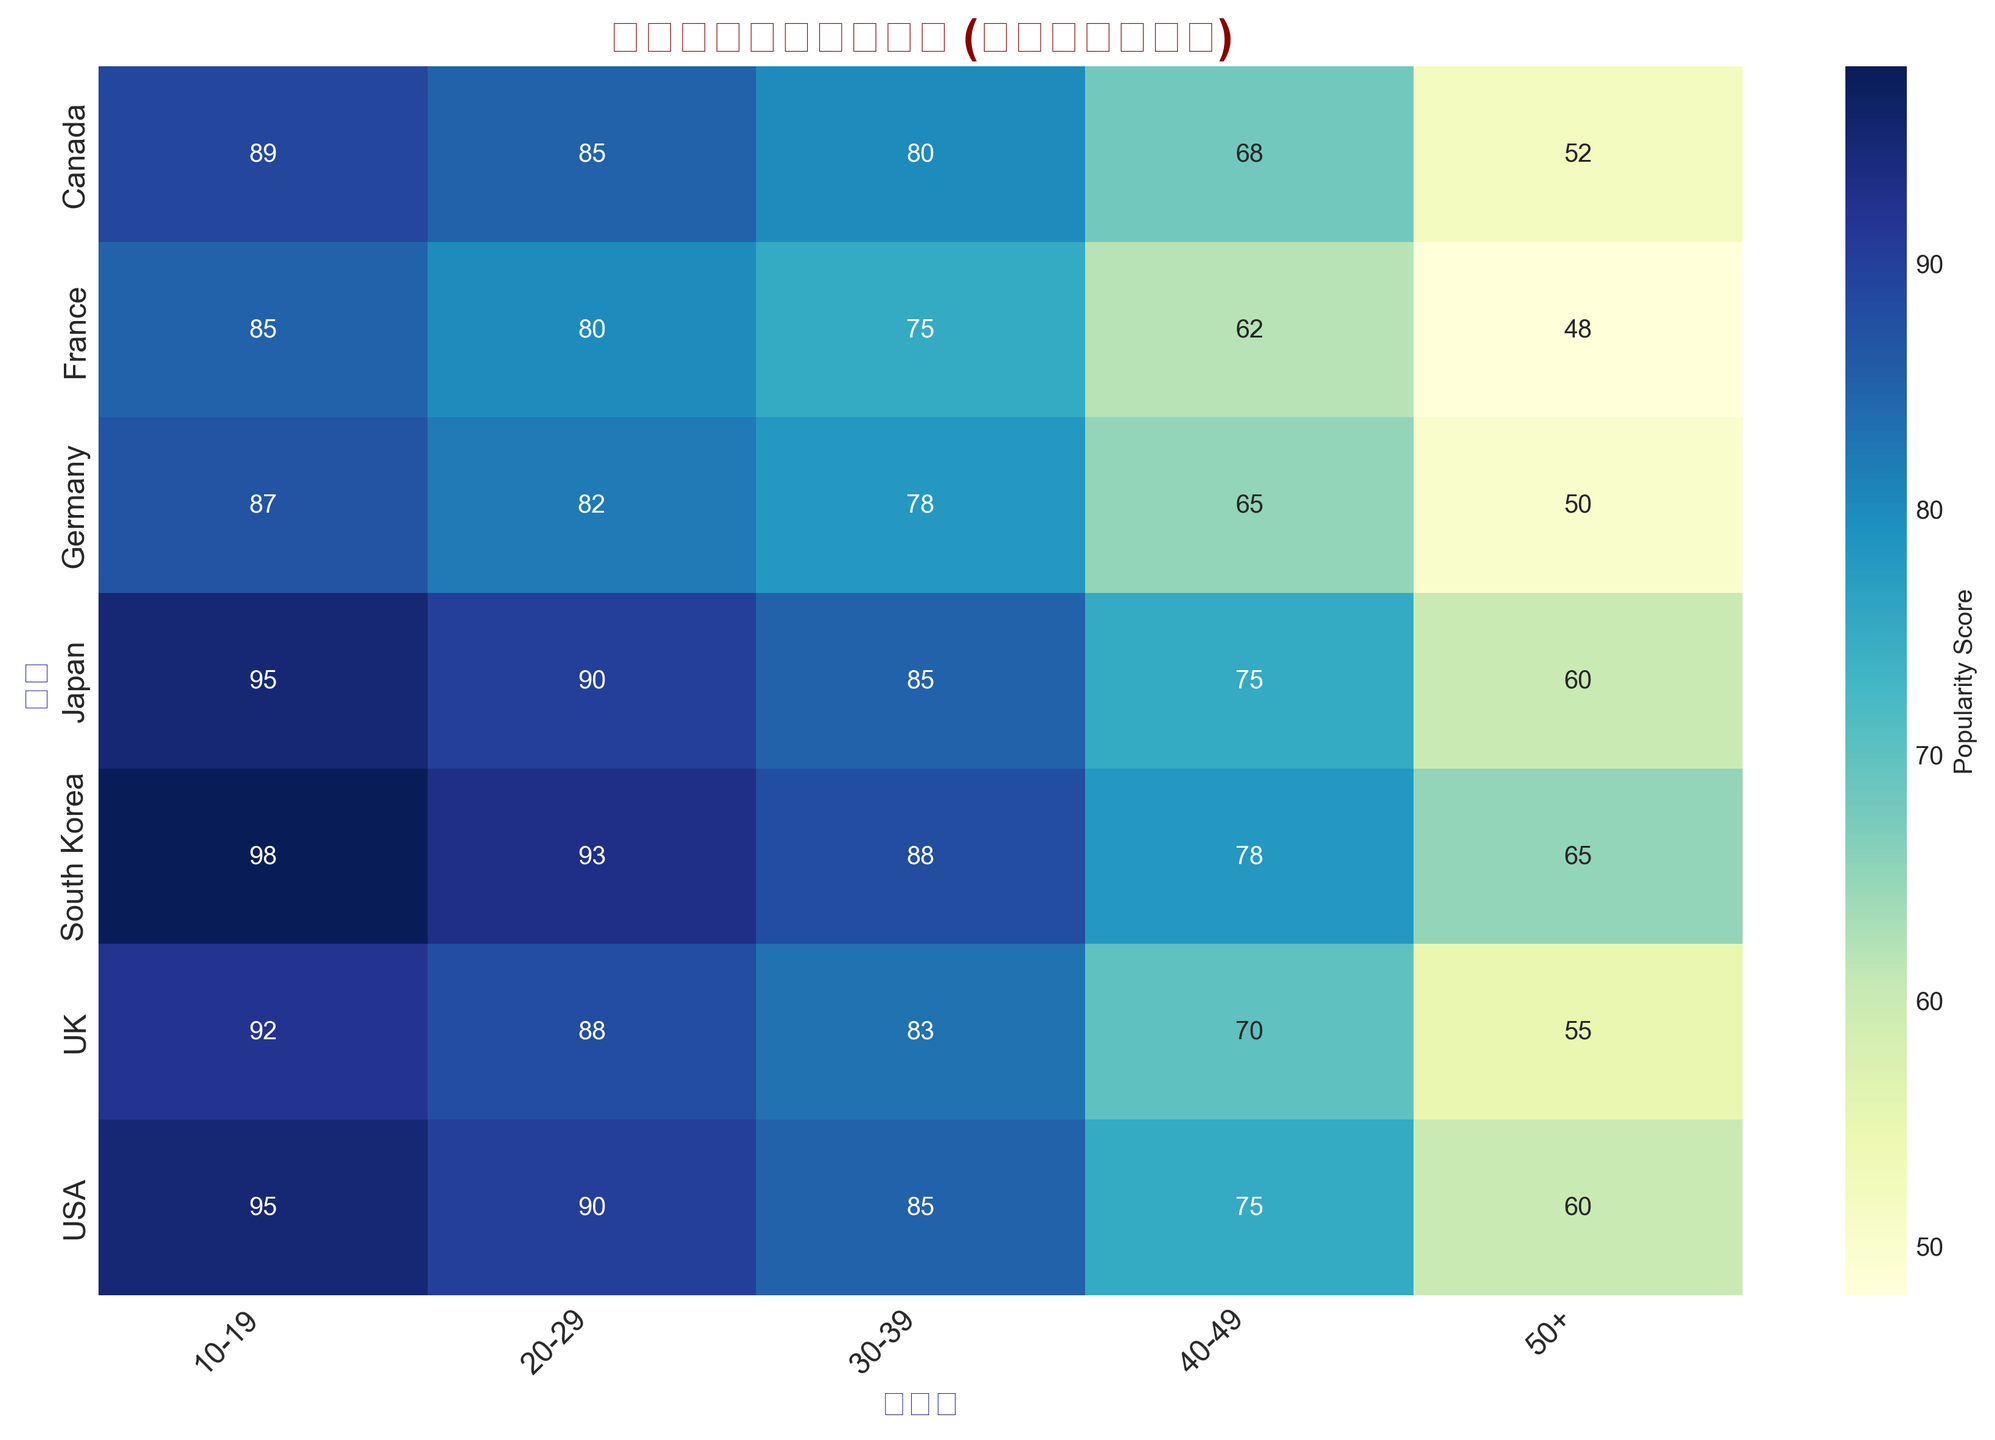Which country has the highest popularity score for the 10-19 age group? To find the country with the highest popularity score for the 10-19 age group, look at the scores in the first column under "10-19". South Korea has the highest value of 98.
Answer: South Korea Which country's popularity score shows the largest decrease from the 10-19 age group to the 50+ age group? Calculate the difference between the scores for the 10-19 and 50+ age groups for each country. The differences are USA: 35, UK: 37, Canada: 37, Germany: 37, France: 37, Japan: 35, South Korea: 33. UK's, Canada's, Germany's, and France's scores drop by 37 which is the largest with respect to others.
Answer: UK, Canada, Germany, France What's the average popularity score for South Korea across all age groups? Sum the popularity scores of South Korea across all age groups and then divide by the number of age groups: (98 + 93 + 88 + 78 + 65) / 5 = 84.4.
Answer: 84.4 In which age group does Japan have the same popularity score as the USA? Compare the values for Japan and USA across all age groups. The values match in the 10-19 (both 95) and 50+ (both 60) age groups.
Answer: 10-19, 50+ Between the age groups 20-29 and 30-39, which country shows the smallest drop in popularity score? Find the difference in scores for the age groups 20-29 and 30-39 for each country: USA: 5, UK: 5, Canada: 5, Germany: 4, France: 5, Japan: 5, South Korea: 5. Germany shows the smallest drop of 4.
Answer: Germany What is the total popularity score for the age group 40-49 across all countries? Sum the popularity scores for the 40-49 age group across all countries: 75 (USA) + 70 (UK) + 68 (Canada) + 65 (Germany) + 62 (France) + 75 (Japan) + 78 (South Korea) = 493.
Answer: 493 Which age group has the highest average popularity score across all countries? Calculate the average score for each age group:
10-19: (95+92+89+87+85+95+98) / 7 = 91.57,
20-29: (90+88+85+82+80+90+93) / 7 = 86.86,
30-39: (85+83+80+78+75+85+88) / 7 = 82,
40-49: (75+70+68+65+62+75+78) / 7 = 70.43,
50+: (60+55+52+50+48+60+65) / 7 = 55.71. 
The 10-19 age group has the highest average score of 91.57.
Answer: 10-19 How does the popularity score for the age group 50+ in France compare to Germany? Directly compare the respective values for the age group 50+: France has 48, Germany has 50. 48 is lower than 50.
Answer: Lower Which country has the most consistent popularity score across all age groups? Check the variability of the scores for each country. The country with the smallest range (difference between highest and lowest scores) is most consistent:
USA: 95-60=35,
UK: 92-55=37,
Canada: 89-52=37,
Germany: 87-50=37,
France: 85-48=37,
Japan: 95-60=35,
South Korea: 98-65=33. 
South Korea has the most consistent scores with a range of 33.
Answer: South Korea 